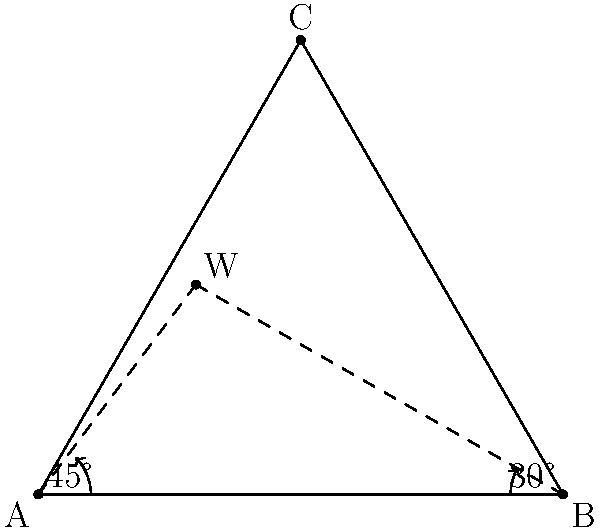In a community well-digging project, you're using triangulation to locate a water source. From point A, you measure an angle of 45° to the water source (W). From point B, 100 meters away from A, you measure a 30° angle to W. Point C is 86.6 meters from both A and B, forming an equilateral triangle. Calculate the distance from point A to the water source W. Let's solve this step-by-step using the law of sines:

1) In triangle ABW, we know:
   - The distance AB = 100 meters
   - Angle at A = 45°
   - Angle at B = 30°

2) The remaining angle in triangle ABW:
   $180° - 45° - 30° = 105°$

3) Apply the law of sines:
   $$\frac{AW}{\sin 30°} = \frac{100}{\sin 105°}$$

4) Solve for AW:
   $$AW = \frac{100 \sin 30°}{\sin 105°}$$

5) Calculate:
   $$AW = \frac{100 \cdot 0.5}{0.9659} \approx 51.76$$

Therefore, the distance from point A to the water source W is approximately 51.76 meters.
Answer: 51.76 meters 